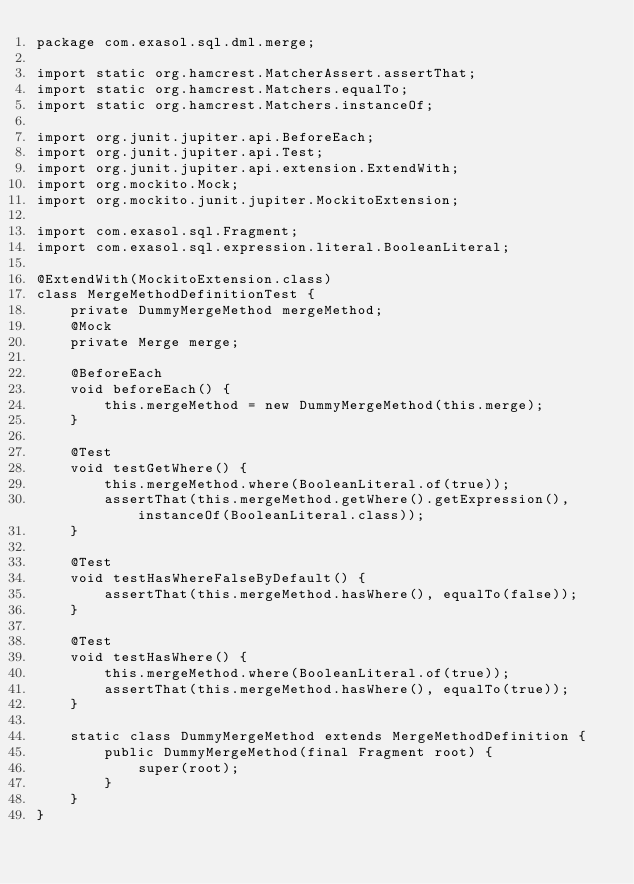Convert code to text. <code><loc_0><loc_0><loc_500><loc_500><_Java_>package com.exasol.sql.dml.merge;

import static org.hamcrest.MatcherAssert.assertThat;
import static org.hamcrest.Matchers.equalTo;
import static org.hamcrest.Matchers.instanceOf;

import org.junit.jupiter.api.BeforeEach;
import org.junit.jupiter.api.Test;
import org.junit.jupiter.api.extension.ExtendWith;
import org.mockito.Mock;
import org.mockito.junit.jupiter.MockitoExtension;

import com.exasol.sql.Fragment;
import com.exasol.sql.expression.literal.BooleanLiteral;

@ExtendWith(MockitoExtension.class)
class MergeMethodDefinitionTest {
    private DummyMergeMethod mergeMethod;
    @Mock
    private Merge merge;

    @BeforeEach
    void beforeEach() {
        this.mergeMethod = new DummyMergeMethod(this.merge);
    }

    @Test
    void testGetWhere() {
        this.mergeMethod.where(BooleanLiteral.of(true));
        assertThat(this.mergeMethod.getWhere().getExpression(), instanceOf(BooleanLiteral.class));
    }

    @Test
    void testHasWhereFalseByDefault() {
        assertThat(this.mergeMethod.hasWhere(), equalTo(false));
    }

    @Test
    void testHasWhere() {
        this.mergeMethod.where(BooleanLiteral.of(true));
        assertThat(this.mergeMethod.hasWhere(), equalTo(true));
    }

    static class DummyMergeMethod extends MergeMethodDefinition {
        public DummyMergeMethod(final Fragment root) {
            super(root);
        }
    }
}</code> 